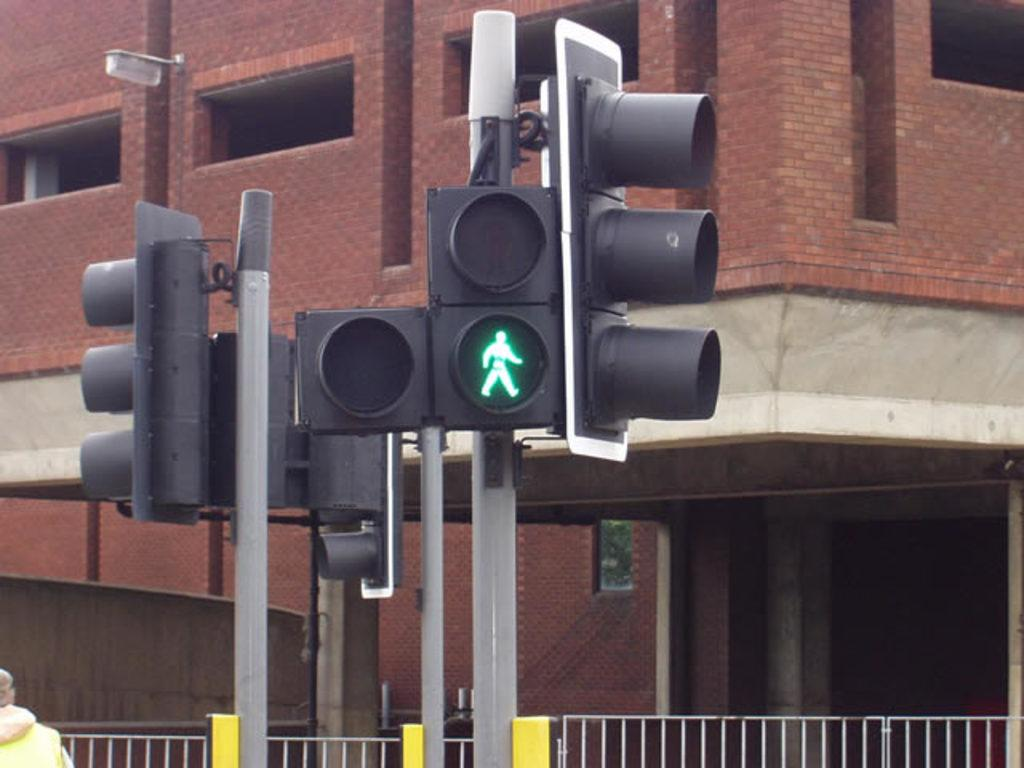What color is the traffic signal pole in the image? The traffic signal pole in the image is black. What color is the brick building in the image? The brick building in the image is red. What type of barrier is present at the bottom of the image? There is a fencing grill at the front bottom side of the image. Reasoning: Let's think step by step by step in order to produce the conversation. We start by identifying the main subjects in the image, which are the traffic signal pole and the brick building. Then, we describe their colors to provide more detail about their appearance. Finally, we mention the fencing grill at the bottom of the image to complete the description of the scene. Each question is designed to elicit a specific detail about the image that is known from the provided facts. Absurd Question/Answer: What is the history of the smell emanating from the traffic signal pole in the image? There is no mention of any smell in the image, and therefore it is not possible to discuss its history. 